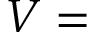Convert formula to latex. <formula><loc_0><loc_0><loc_500><loc_500>V =</formula> 